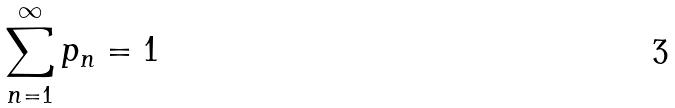<formula> <loc_0><loc_0><loc_500><loc_500>\sum _ { n = 1 } ^ { \infty } p _ { n } = 1</formula> 